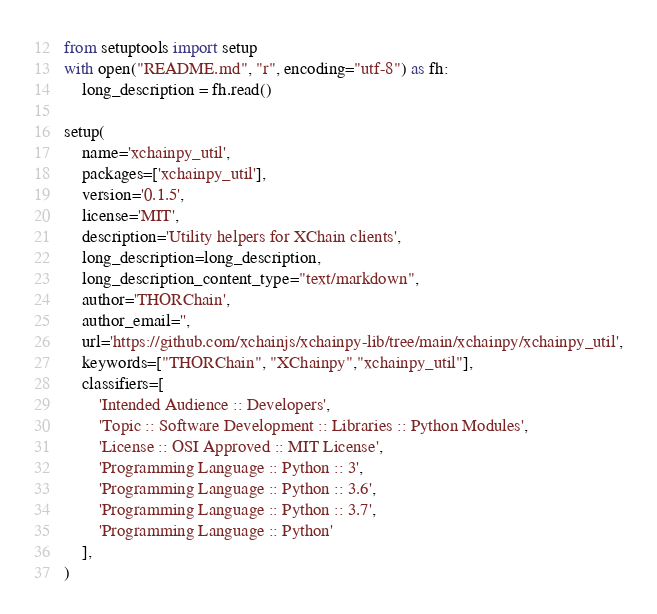<code> <loc_0><loc_0><loc_500><loc_500><_Python_>from setuptools import setup
with open("README.md", "r", encoding="utf-8") as fh:
    long_description = fh.read()

setup(
    name='xchainpy_util',
    packages=['xchainpy_util'],
    version='0.1.5',
    license='MIT',
    description='Utility helpers for XChain clients',
    long_description=long_description,
    long_description_content_type="text/markdown",
    author='THORChain',
    author_email='',
    url='https://github.com/xchainjs/xchainpy-lib/tree/main/xchainpy/xchainpy_util',
    keywords=["THORChain", "XChainpy","xchainpy_util"],
    classifiers=[
        'Intended Audience :: Developers',
        'Topic :: Software Development :: Libraries :: Python Modules',
        'License :: OSI Approved :: MIT License',
        'Programming Language :: Python :: 3',
        'Programming Language :: Python :: 3.6',
        'Programming Language :: Python :: 3.7',
        'Programming Language :: Python'
    ],
)</code> 